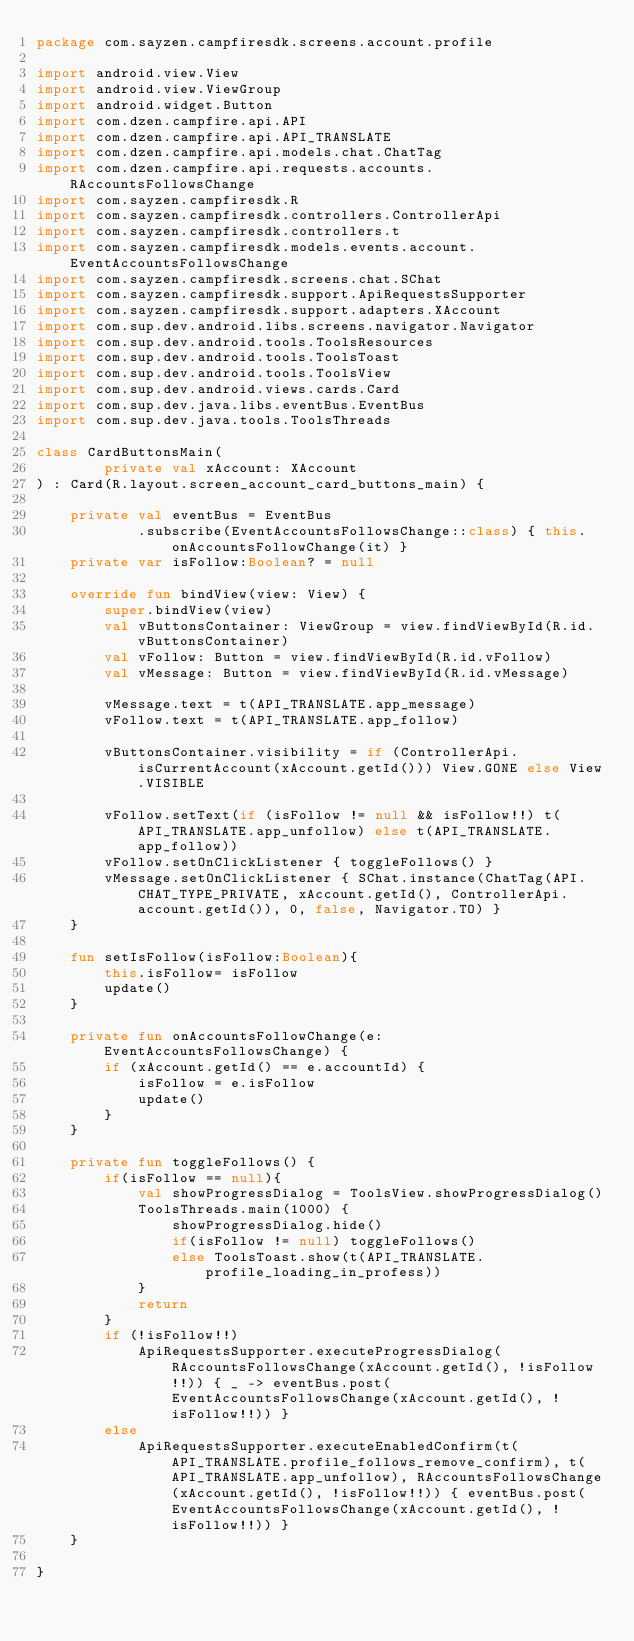Convert code to text. <code><loc_0><loc_0><loc_500><loc_500><_Kotlin_>package com.sayzen.campfiresdk.screens.account.profile

import android.view.View
import android.view.ViewGroup
import android.widget.Button
import com.dzen.campfire.api.API
import com.dzen.campfire.api.API_TRANSLATE
import com.dzen.campfire.api.models.chat.ChatTag
import com.dzen.campfire.api.requests.accounts.RAccountsFollowsChange
import com.sayzen.campfiresdk.R
import com.sayzen.campfiresdk.controllers.ControllerApi
import com.sayzen.campfiresdk.controllers.t
import com.sayzen.campfiresdk.models.events.account.EventAccountsFollowsChange
import com.sayzen.campfiresdk.screens.chat.SChat
import com.sayzen.campfiresdk.support.ApiRequestsSupporter
import com.sayzen.campfiresdk.support.adapters.XAccount
import com.sup.dev.android.libs.screens.navigator.Navigator
import com.sup.dev.android.tools.ToolsResources
import com.sup.dev.android.tools.ToolsToast
import com.sup.dev.android.tools.ToolsView
import com.sup.dev.android.views.cards.Card
import com.sup.dev.java.libs.eventBus.EventBus
import com.sup.dev.java.tools.ToolsThreads

class CardButtonsMain(
        private val xAccount: XAccount
) : Card(R.layout.screen_account_card_buttons_main) {

    private val eventBus = EventBus
            .subscribe(EventAccountsFollowsChange::class) { this.onAccountsFollowChange(it) }
    private var isFollow:Boolean? = null

    override fun bindView(view: View) {
        super.bindView(view)
        val vButtonsContainer: ViewGroup = view.findViewById(R.id.vButtonsContainer)
        val vFollow: Button = view.findViewById(R.id.vFollow)
        val vMessage: Button = view.findViewById(R.id.vMessage)

        vMessage.text = t(API_TRANSLATE.app_message)
        vFollow.text = t(API_TRANSLATE.app_follow)

        vButtonsContainer.visibility = if (ControllerApi.isCurrentAccount(xAccount.getId())) View.GONE else View.VISIBLE

        vFollow.setText(if (isFollow != null && isFollow!!) t(API_TRANSLATE.app_unfollow) else t(API_TRANSLATE.app_follow))
        vFollow.setOnClickListener { toggleFollows() }
        vMessage.setOnClickListener { SChat.instance(ChatTag(API.CHAT_TYPE_PRIVATE, xAccount.getId(), ControllerApi.account.getId()), 0, false, Navigator.TO) }
    }

    fun setIsFollow(isFollow:Boolean){
        this.isFollow= isFollow
        update()
    }

    private fun onAccountsFollowChange(e: EventAccountsFollowsChange) {
        if (xAccount.getId() == e.accountId) {
            isFollow = e.isFollow
            update()
        }
    }

    private fun toggleFollows() {
        if(isFollow == null){
            val showProgressDialog = ToolsView.showProgressDialog()
            ToolsThreads.main(1000) {
                showProgressDialog.hide()
                if(isFollow != null) toggleFollows()
                else ToolsToast.show(t(API_TRANSLATE.profile_loading_in_profess))
            }
            return
        }
        if (!isFollow!!)
            ApiRequestsSupporter.executeProgressDialog(RAccountsFollowsChange(xAccount.getId(), !isFollow!!)) { _ -> eventBus.post(EventAccountsFollowsChange(xAccount.getId(), !isFollow!!)) }
        else
            ApiRequestsSupporter.executeEnabledConfirm(t(API_TRANSLATE.profile_follows_remove_confirm), t(API_TRANSLATE.app_unfollow), RAccountsFollowsChange(xAccount.getId(), !isFollow!!)) { eventBus.post(EventAccountsFollowsChange(xAccount.getId(), !isFollow!!)) }
    }

}
</code> 